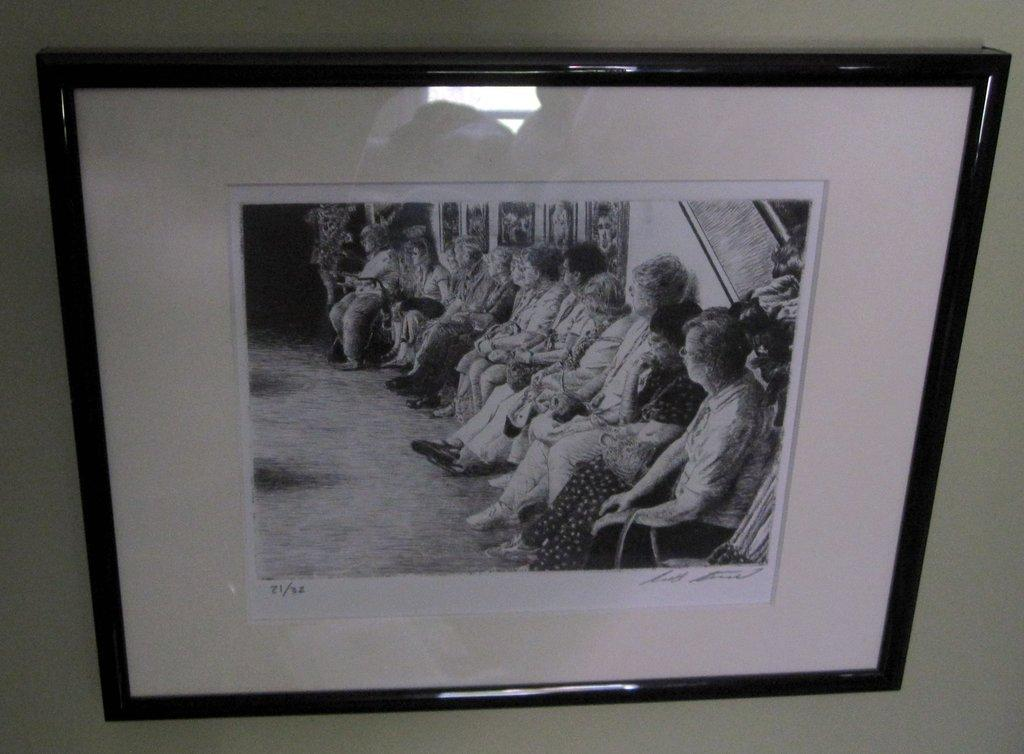<image>
Give a short and clear explanation of the subsequent image. A picture of some women has the number 21 in the corner 